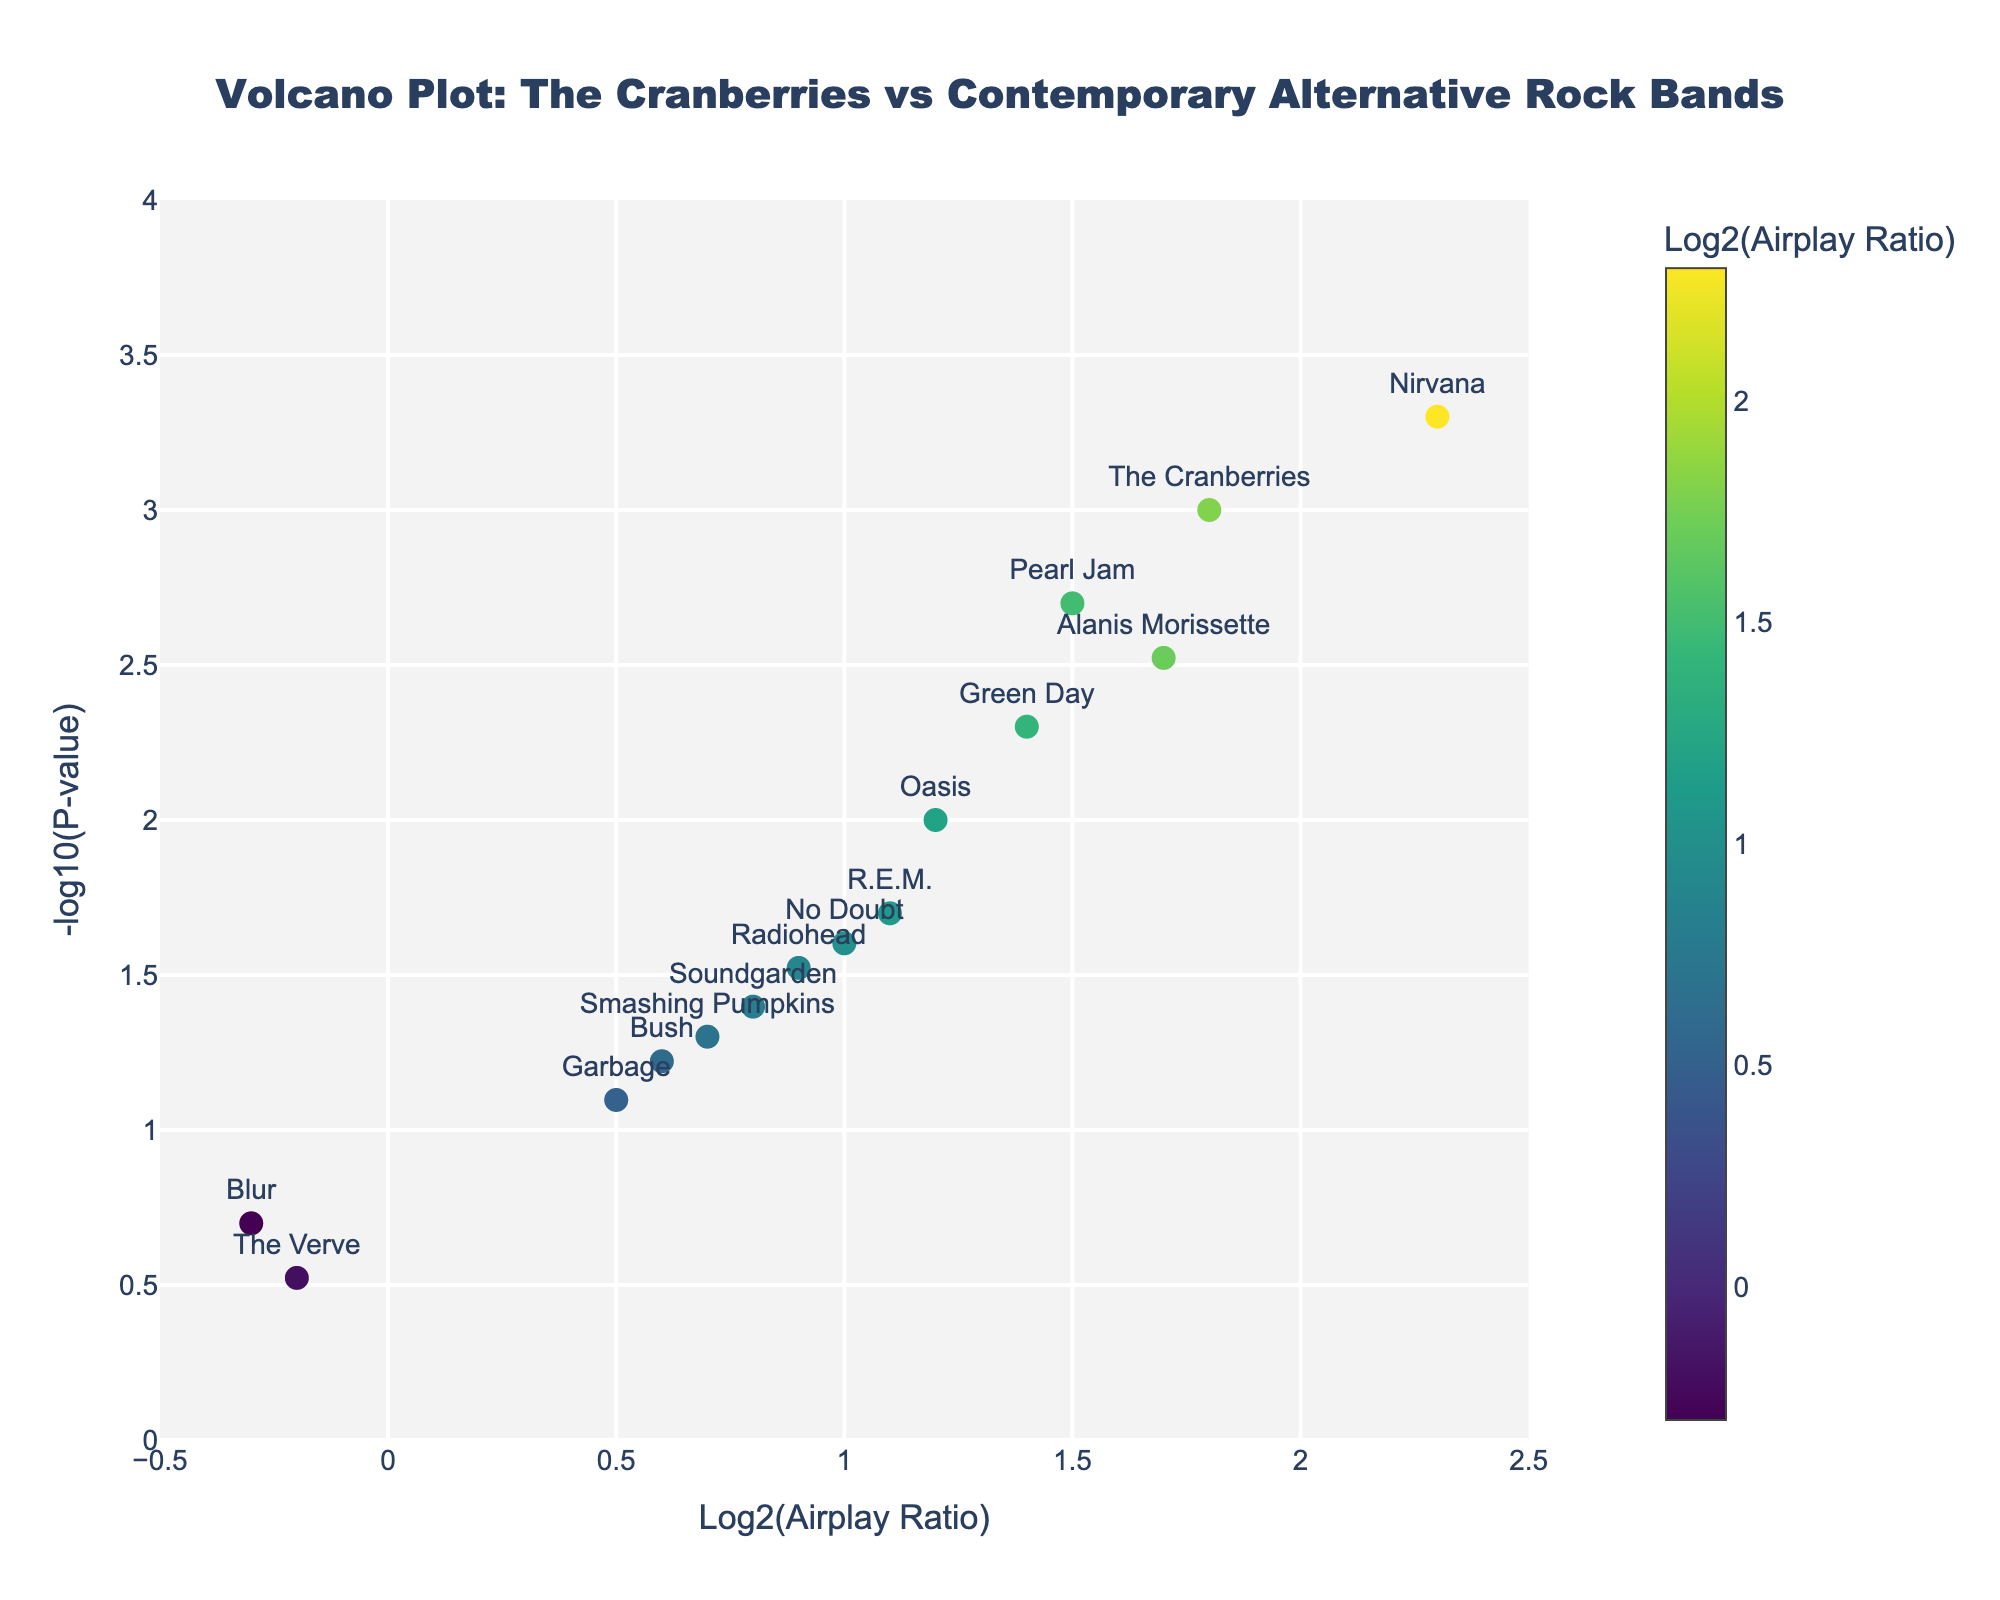What's the title of the figure? The title is displayed prominently at the top of the figure.
Answer: Volcano Plot: The Cranberries vs Contemporary Alternative Rock Bands What are the axes titles in the plot? The x-axis title is "Log2(Airplay Ratio)" and the y-axis title is "-log10(P-value)".
Answer: Log2(Airplay Ratio), -log10(P-value) How many bands are represented in the plot? Each marker on the plot represents a band, and there are 15 markers in total.
Answer: 15 Which band has the highest Log2(Airplay Ratio)? By looking at the x-axis where the Log2(Airplay Ratio) values are plotted, Nirvana has the highest value at 2.3.
Answer: Nirvana Which band has the smallest -log10(P-value)? By looking at the y-axis which represents -log10(P-value), the band with the smallest value is Blur with a -log10(P-value) around -0.3.
Answer: Blur How does The Cranberries' Log2(Airplay Ratio) compare to Pearl Jam's? The Cranberries have a Log2(Airplay Ratio) of 1.8, while Pearl Jam has a ratio of 1.5. Therefore, The Cranberries have a higher Log2(Airplay Ratio) than Pearl Jam.
Answer: The Cranberries Which band is closest to the origin (0, 0) on the plot? The band closest to (0, 0) would have both the smallest Log2(Airplay Ratio) and the smallest -log10(P-value). Blur, with Log2(Airplay Ratio) of -0.3 and a P-value that translates to around -1 on the -log10 scale, fits this description.
Answer: Blur For which bands is the airplay ratio statistically significant? (P-value < 0.05) Bands with a -log10(P-value) greater than 1.3 meet the P-value threshold. These bands are The Cranberries, Nirvana, Pearl Jam, Alanis Morissette, Green Day, R.E.M., No Doubt, Oasis, and Soundgarden.
Answer: The Cranberries, Nirvana, Pearl Jam, Alanis Morissette, Green Day, R.E.M., No Doubt, Oasis, Soundgarden Which two bands have the closest Log2(Airplay Ratio) values? By examining the x-axis positions, Radiohead and No Doubt both have Log2(Airplay Ratio) around 1.0, making their values closest to each other.
Answer: Radiohead and No Doubt What is the average Log2(Airplay Ratio) of all bands with statistically significant airplay ratios? First, identify bands with -log10(P-value) > 1.3. Their Log2(Airplay Ratio) values are: 1.8, 2.3, 1.5, 1.7, 1.4, 1.1, 1.0, 1.2, 0.8. Sum these values: 12.8 and divide by the number of bands (9).
Answer: 1.42 